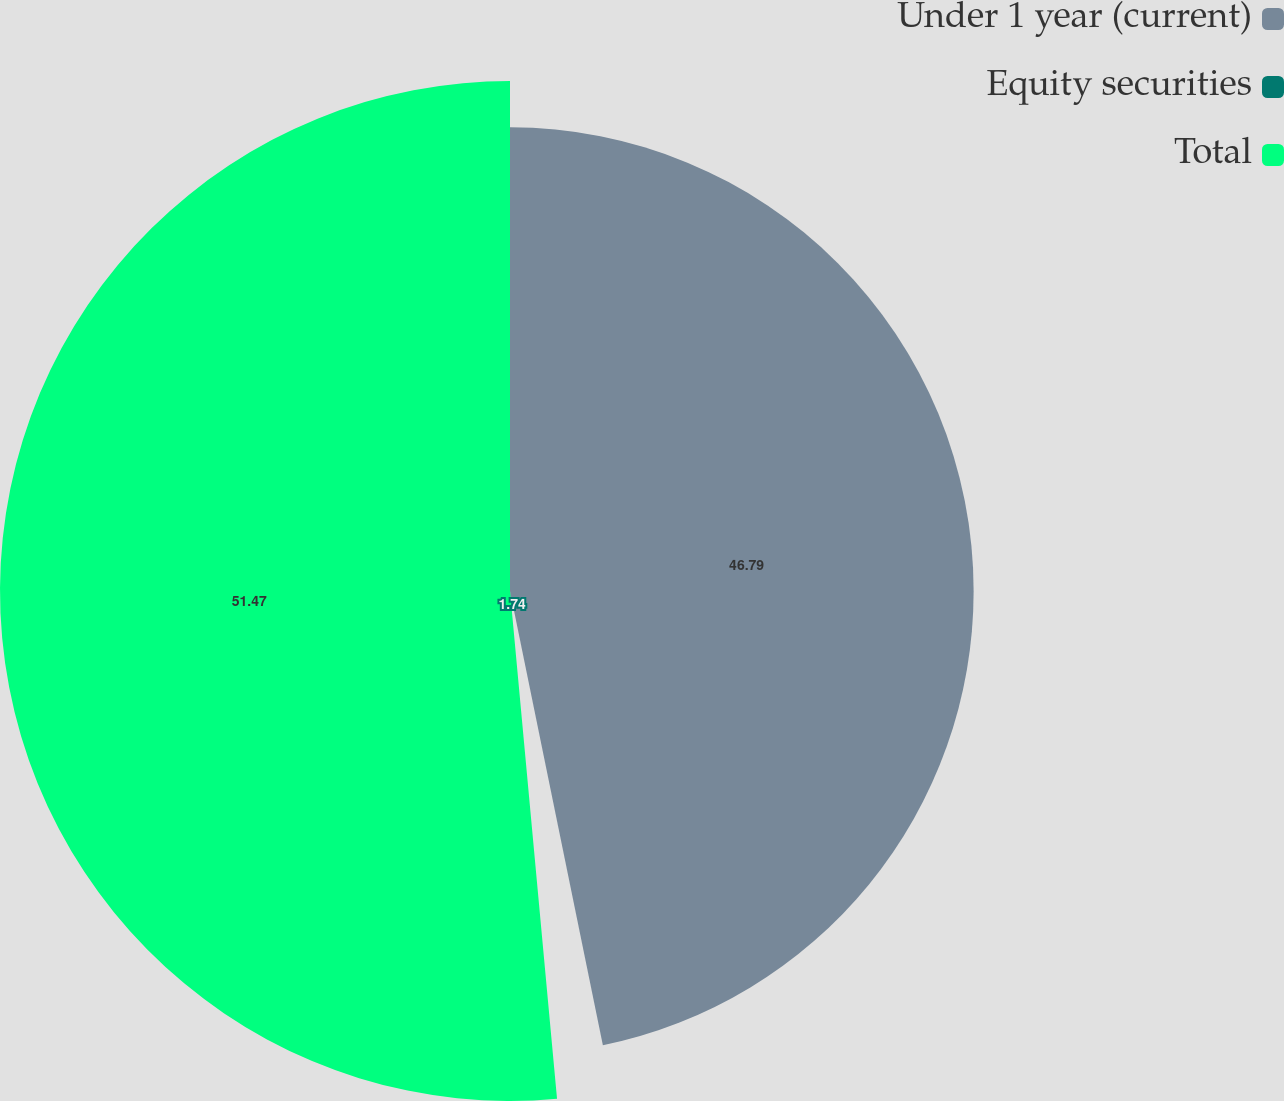Convert chart to OTSL. <chart><loc_0><loc_0><loc_500><loc_500><pie_chart><fcel>Under 1 year (current)<fcel>Equity securities<fcel>Total<nl><fcel>46.79%<fcel>1.74%<fcel>51.47%<nl></chart> 